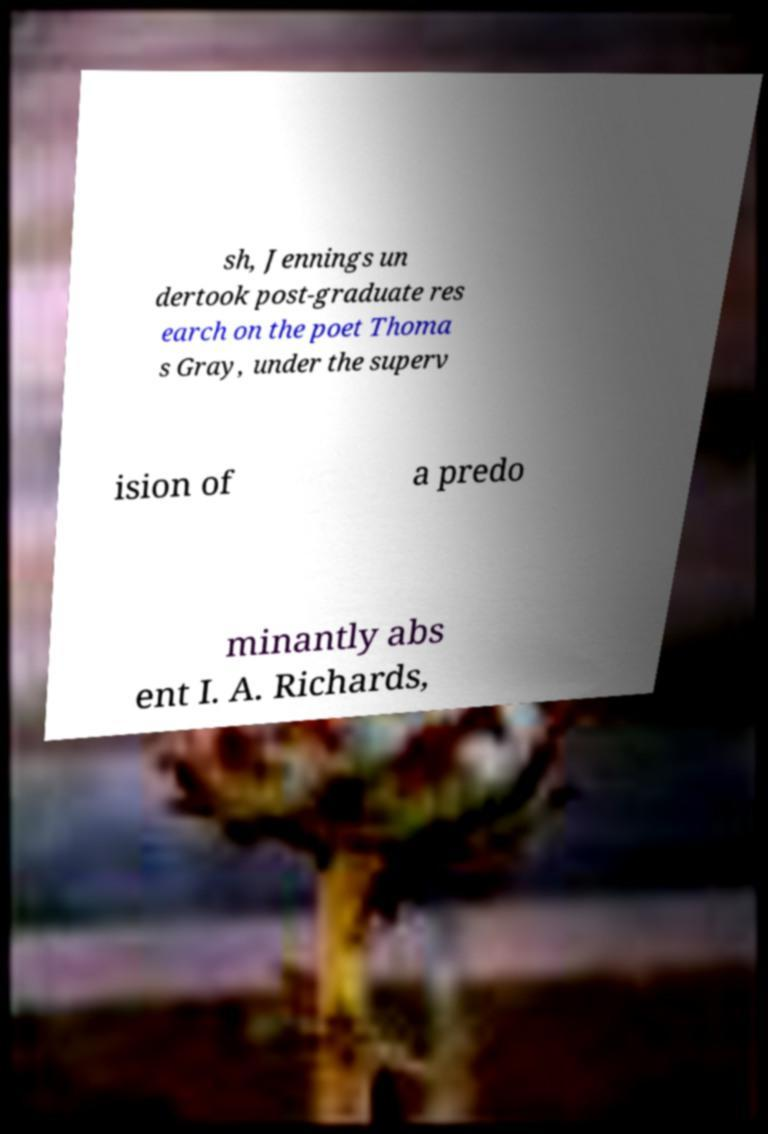Could you assist in decoding the text presented in this image and type it out clearly? sh, Jennings un dertook post-graduate res earch on the poet Thoma s Gray, under the superv ision of a predo minantly abs ent I. A. Richards, 